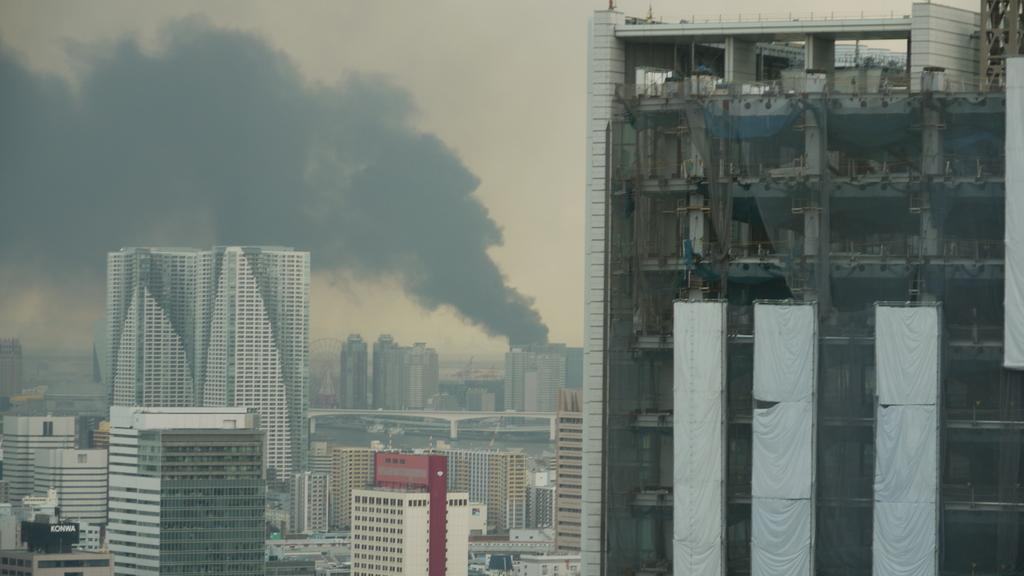What type of structures can be seen in the image? There are buildings in the image. What is present in the sky in the image? There is smoke visible in the sky. Where is the sofa located in the image? There is no sofa present in the image. What type of jelly can be seen on the buildings in the image? There is no jelly present on the buildings in the image. 